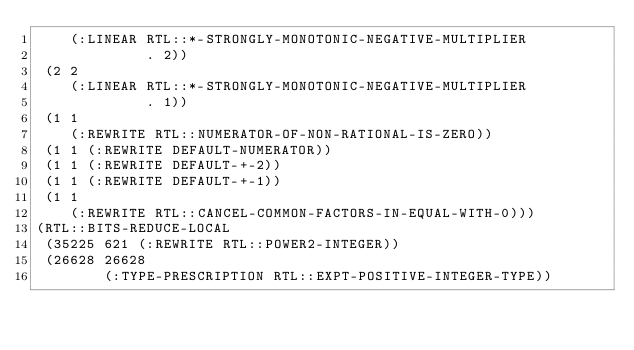<code> <loc_0><loc_0><loc_500><loc_500><_Lisp_>    (:LINEAR RTL::*-STRONGLY-MONOTONIC-NEGATIVE-MULTIPLIER
             . 2))
 (2 2
    (:LINEAR RTL::*-STRONGLY-MONOTONIC-NEGATIVE-MULTIPLIER
             . 1))
 (1 1
    (:REWRITE RTL::NUMERATOR-OF-NON-RATIONAL-IS-ZERO))
 (1 1 (:REWRITE DEFAULT-NUMERATOR))
 (1 1 (:REWRITE DEFAULT-+-2))
 (1 1 (:REWRITE DEFAULT-+-1))
 (1 1
    (:REWRITE RTL::CANCEL-COMMON-FACTORS-IN-EQUAL-WITH-0)))
(RTL::BITS-REDUCE-LOCAL
 (35225 621 (:REWRITE RTL::POWER2-INTEGER))
 (26628 26628
        (:TYPE-PRESCRIPTION RTL::EXPT-POSITIVE-INTEGER-TYPE))</code> 